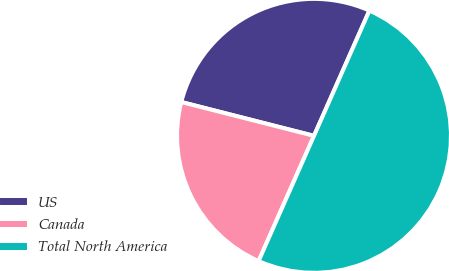<chart> <loc_0><loc_0><loc_500><loc_500><pie_chart><fcel>US<fcel>Canada<fcel>Total North America<nl><fcel>27.66%<fcel>22.34%<fcel>50.0%<nl></chart> 